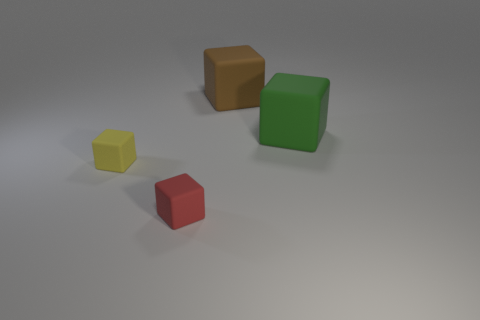Is the material of the small object that is behind the tiny red rubber thing the same as the small red object?
Your response must be concise. Yes. The small rubber thing that is right of the rubber cube that is on the left side of the tiny matte object that is right of the yellow thing is what shape?
Your response must be concise. Cube. Are there an equal number of big brown things that are to the right of the brown block and things behind the yellow matte object?
Offer a very short reply. No. There is a thing that is the same size as the yellow matte block; what color is it?
Your answer should be very brief. Red. How many large things are either red matte cubes or cyan matte things?
Provide a succinct answer. 0. What is the material of the cube that is right of the small red block and left of the large green object?
Offer a very short reply. Rubber. There is a small rubber thing in front of the yellow thing; is it the same shape as the big thing that is behind the large green rubber cube?
Your answer should be compact. Yes. How many objects are either small objects that are behind the small red cube or rubber cubes?
Give a very brief answer. 4. Is the red cube the same size as the green object?
Give a very brief answer. No. The tiny thing left of the red rubber block is what color?
Provide a short and direct response. Yellow. 